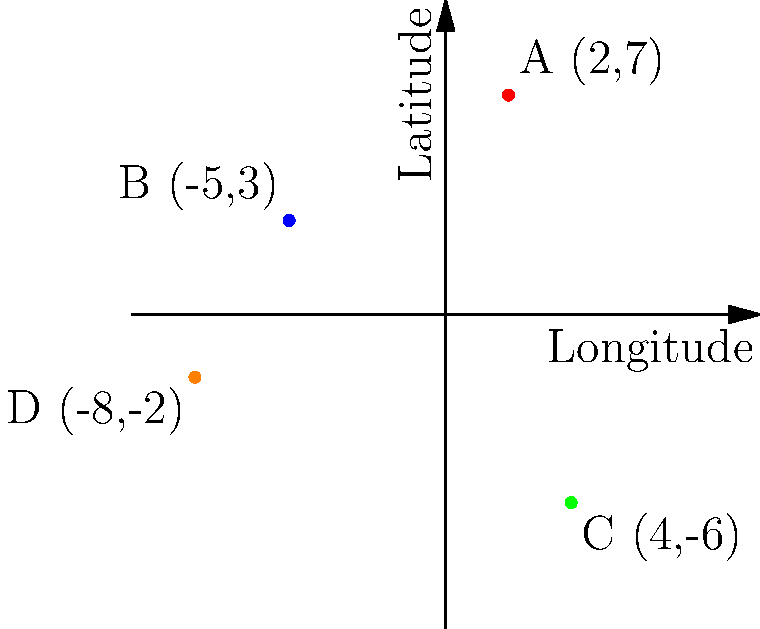As a corporate law aspirant, you're analyzing the geographic distribution of major law firms across the country. The map above shows the locations of four prominent firms (A, B, C, and D) using a coordinate system where the x-axis represents longitude and the y-axis represents latitude. Which two firms are located the furthest apart from each other, and what is the distance between them (rounded to the nearest whole number)? To solve this problem, we need to calculate the distance between each pair of firms and find the largest distance. We'll use the distance formula derived from the Pythagorean theorem:

Distance = $\sqrt{(x_2-x_1)^2 + (y_2-y_1)^2}$

Let's calculate the distance between each pair:

1. A and B: $\sqrt{(2-(-5))^2 + (7-3)^2} = \sqrt{7^2 + 4^2} = \sqrt{65} \approx 8.06$
2. A and C: $\sqrt{(2-4)^2 + (7-(-6))^2} = \sqrt{(-2)^2 + 13^2} = \sqrt{173} \approx 13.15$
3. A and D: $\sqrt{(2-(-8))^2 + (7-(-2))^2} = \sqrt{10^2 + 9^2} = \sqrt{181} \approx 13.45$
4. B and C: $\sqrt{(-5-4)^2 + (3-(-6))^2} = \sqrt{(-9)^2 + 9^2} = \sqrt{162} \approx 12.73$
5. B and D: $\sqrt{(-5-(-8))^2 + (3-(-2))^2} = \sqrt{3^2 + 5^2} = \sqrt{34} \approx 5.83$
6. C and D: $\sqrt{(4-(-8))^2 + (-6-(-2))^2} = \sqrt{12^2 + (-4)^2} = \sqrt{160} \approx 12.65$

The largest distance is between firms A and D, approximately 13.45 units.

Rounding to the nearest whole number, we get 13 units.
Answer: Firms A and D; 13 units 